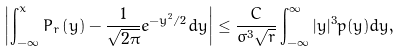<formula> <loc_0><loc_0><loc_500><loc_500>\left | \int _ { - \infty } ^ { x } P _ { r } \left ( y \right ) - \frac { 1 } { \sqrt { 2 \pi } } e ^ { - y ^ { 2 } / 2 } d y \right | \leq \frac { C } { \sigma ^ { 3 } \sqrt { r } } \int _ { - \infty } ^ { \infty } | y | ^ { 3 } p ( y ) d y ,</formula> 